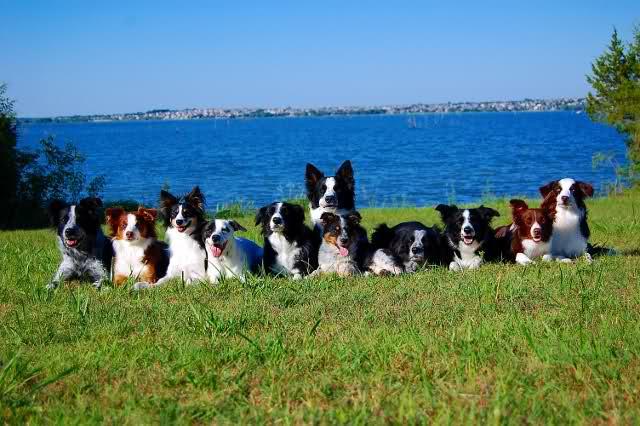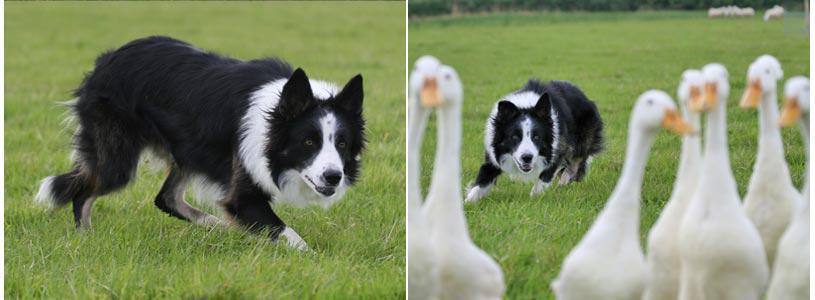The first image is the image on the left, the second image is the image on the right. For the images displayed, is the sentence "There are at most 5 dogs on the left image." factually correct? Answer yes or no. No. The first image is the image on the left, the second image is the image on the right. Evaluate the accuracy of this statement regarding the images: "An image shows a straight row of at least seven dogs reclining on the grass.". Is it true? Answer yes or no. Yes. 